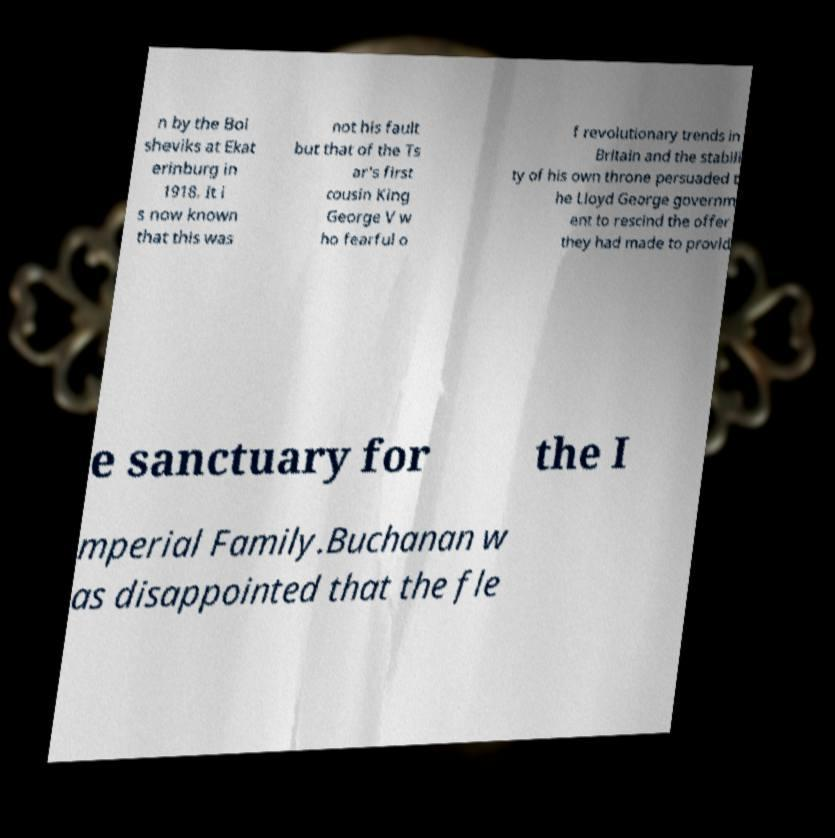Please read and relay the text visible in this image. What does it say? n by the Bol sheviks at Ekat erinburg in 1918. It i s now known that this was not his fault but that of the Ts ar's first cousin King George V w ho fearful o f revolutionary trends in Britain and the stabili ty of his own throne persuaded t he Lloyd George governm ent to rescind the offer they had made to provid e sanctuary for the I mperial Family.Buchanan w as disappointed that the fle 